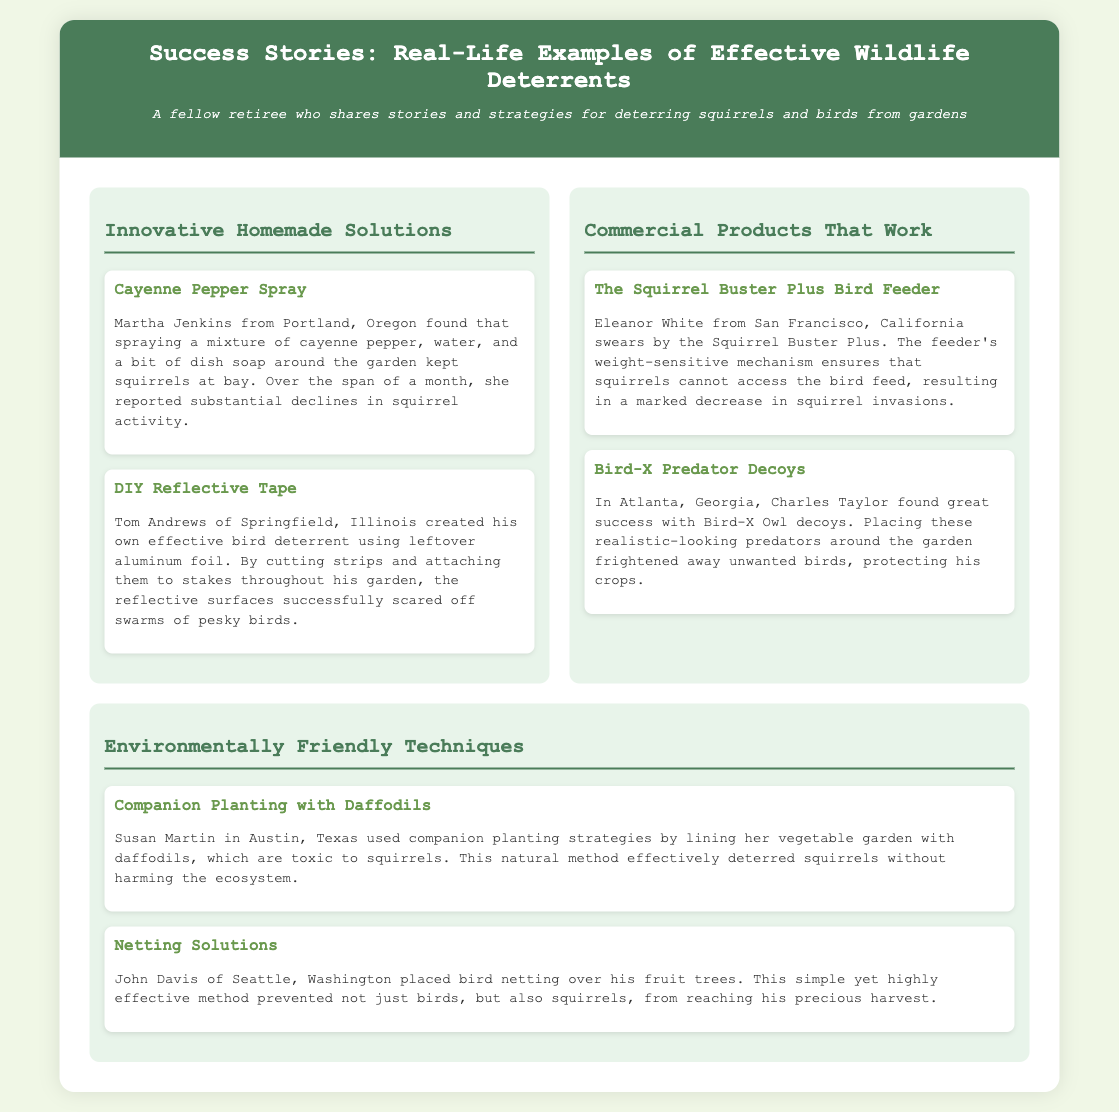What method did Martha Jenkins use to deter squirrels? Martha Jenkins sprayed a mixture of cayenne pepper, water, and dish soap around her garden to keep squirrels at bay.
Answer: Cayenne Pepper Spray What product does Eleanor White recommend? Eleanor White swears by the Squirrel Buster Plus, which has a weight-sensitive mechanism to deter squirrels.
Answer: Squirrel Buster Plus Which environmental technique did Susan Martin employ? Susan Martin used companion planting by lining her garden with daffodils, which are toxic to squirrels.
Answer: Companion Planting with Daffodils What did Tom Andrews make to deter birds? Tom Andrews created an effective bird deterrent by using leftover aluminum foil strips attached to stakes.
Answer: DIY Reflective Tape Which deterrent did Charles Taylor use to protect his crops? Charles Taylor used Bird-X Owl decoys to frighten away unwanted birds from his garden.
Answer: Bird-X Predator Decoys How did John Davis prevent access to fruit trees? John Davis placed bird netting over his fruit trees to prevent birds and squirrels from reaching the harvest.
Answer: Netting Solutions 